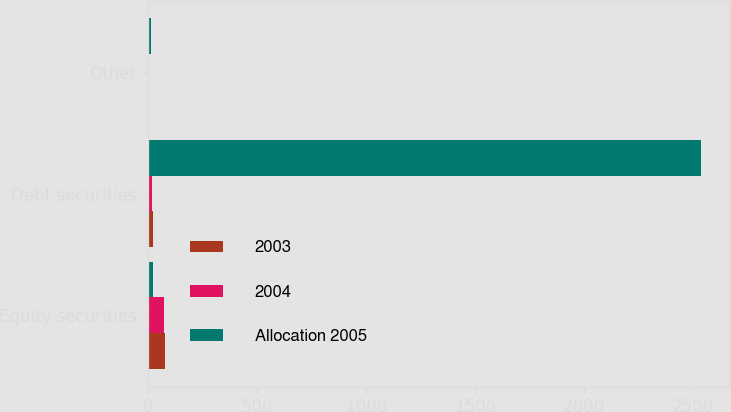Convert chart. <chart><loc_0><loc_0><loc_500><loc_500><stacked_bar_chart><ecel><fcel>Equity securities<fcel>Debt securities<fcel>Other<nl><fcel>2003<fcel>76<fcel>23<fcel>1<nl><fcel>2004<fcel>75<fcel>19<fcel>6<nl><fcel>Allocation 2005<fcel>21<fcel>2540<fcel>15<nl></chart> 